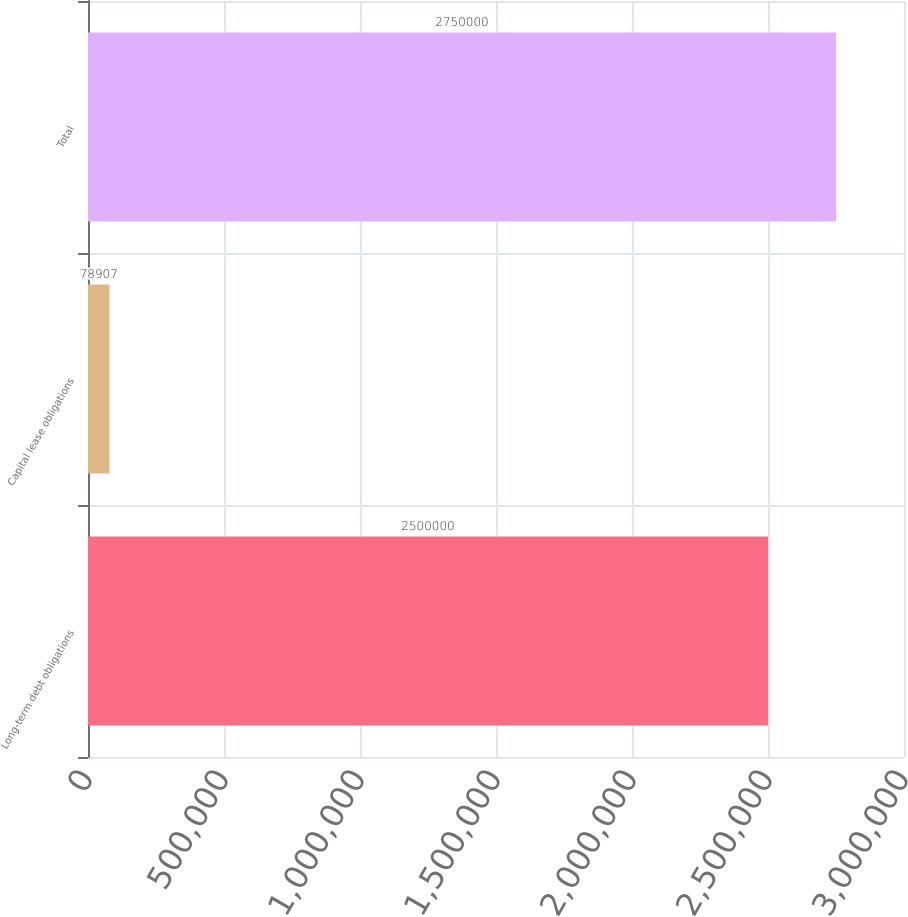<chart> <loc_0><loc_0><loc_500><loc_500><bar_chart><fcel>Long-term debt obligations<fcel>Capital lease obligations<fcel>Total<nl><fcel>2.5e+06<fcel>78907<fcel>2.75e+06<nl></chart> 